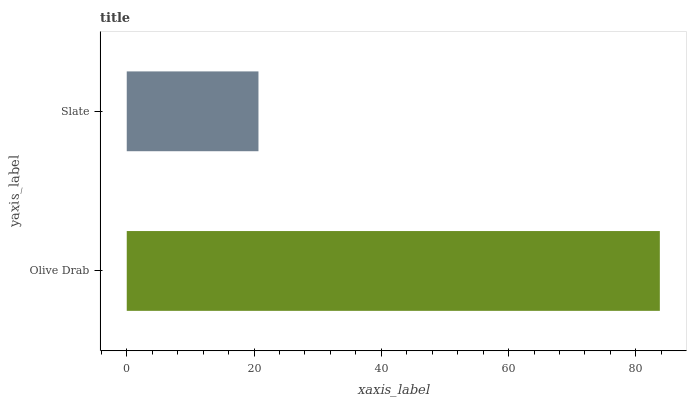Is Slate the minimum?
Answer yes or no. Yes. Is Olive Drab the maximum?
Answer yes or no. Yes. Is Slate the maximum?
Answer yes or no. No. Is Olive Drab greater than Slate?
Answer yes or no. Yes. Is Slate less than Olive Drab?
Answer yes or no. Yes. Is Slate greater than Olive Drab?
Answer yes or no. No. Is Olive Drab less than Slate?
Answer yes or no. No. Is Olive Drab the high median?
Answer yes or no. Yes. Is Slate the low median?
Answer yes or no. Yes. Is Slate the high median?
Answer yes or no. No. Is Olive Drab the low median?
Answer yes or no. No. 